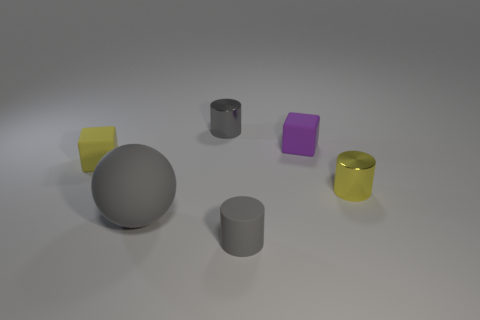Are there any other things that have the same size as the matte sphere?
Ensure brevity in your answer.  No. What number of other cylinders are the same color as the rubber cylinder?
Ensure brevity in your answer.  1. What is the size of the gray ball that is the same material as the small purple block?
Provide a succinct answer. Large. What number of green things are either big objects or rubber cylinders?
Your response must be concise. 0. There is a metal cylinder that is behind the purple matte object; how many small yellow rubber things are to the left of it?
Provide a short and direct response. 1. Is the number of rubber objects in front of the yellow shiny object greater than the number of gray matte spheres behind the large matte ball?
Give a very brief answer. Yes. What is the material of the tiny yellow cylinder?
Your answer should be compact. Metal. Is there a gray matte cylinder that has the same size as the yellow rubber thing?
Make the answer very short. Yes. What material is the yellow cube that is the same size as the purple rubber cube?
Provide a succinct answer. Rubber. How many large gray things are there?
Ensure brevity in your answer.  1. 